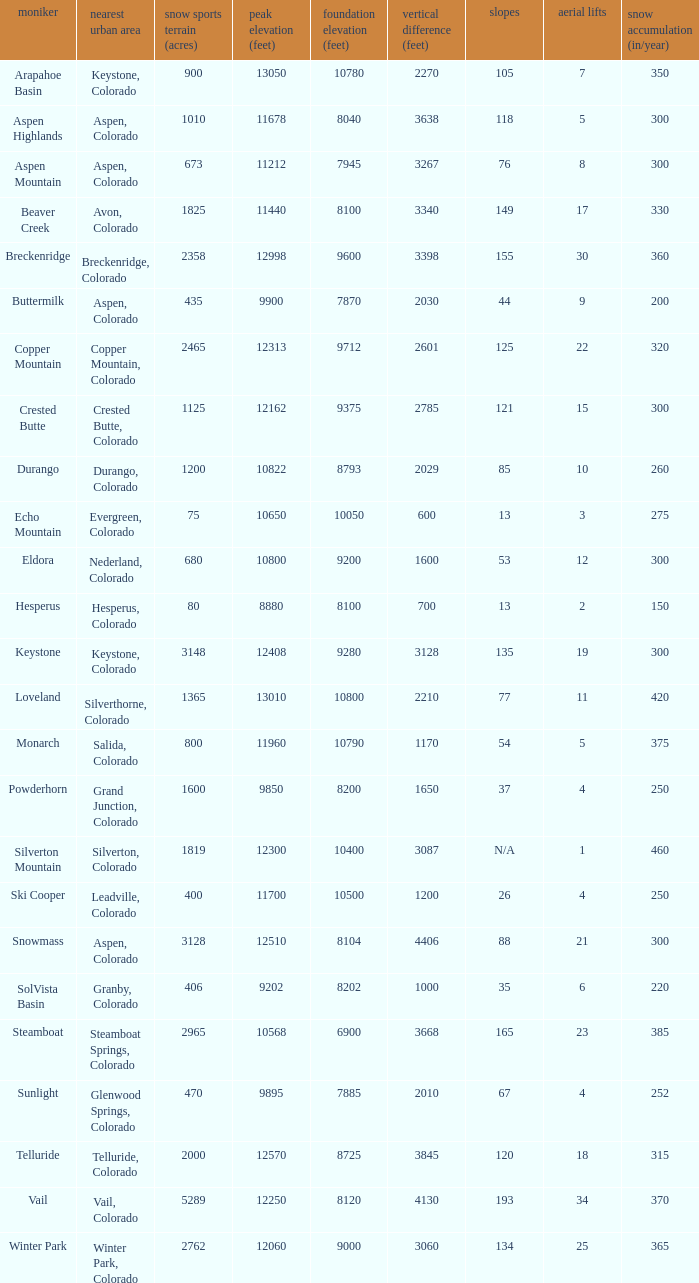If there are 11 lifts, what is the base elevation? 10800.0. 